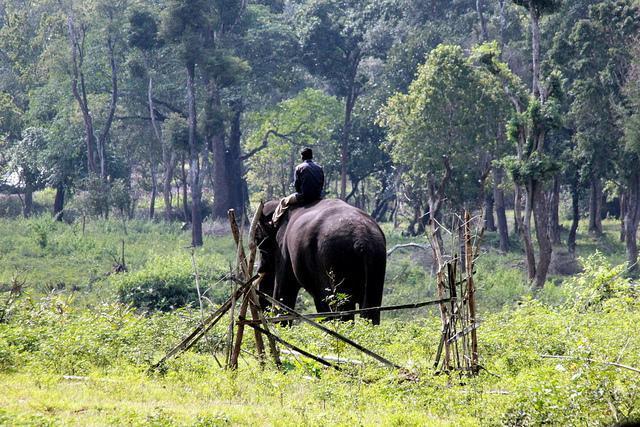How many people are riding?
Give a very brief answer. 1. 